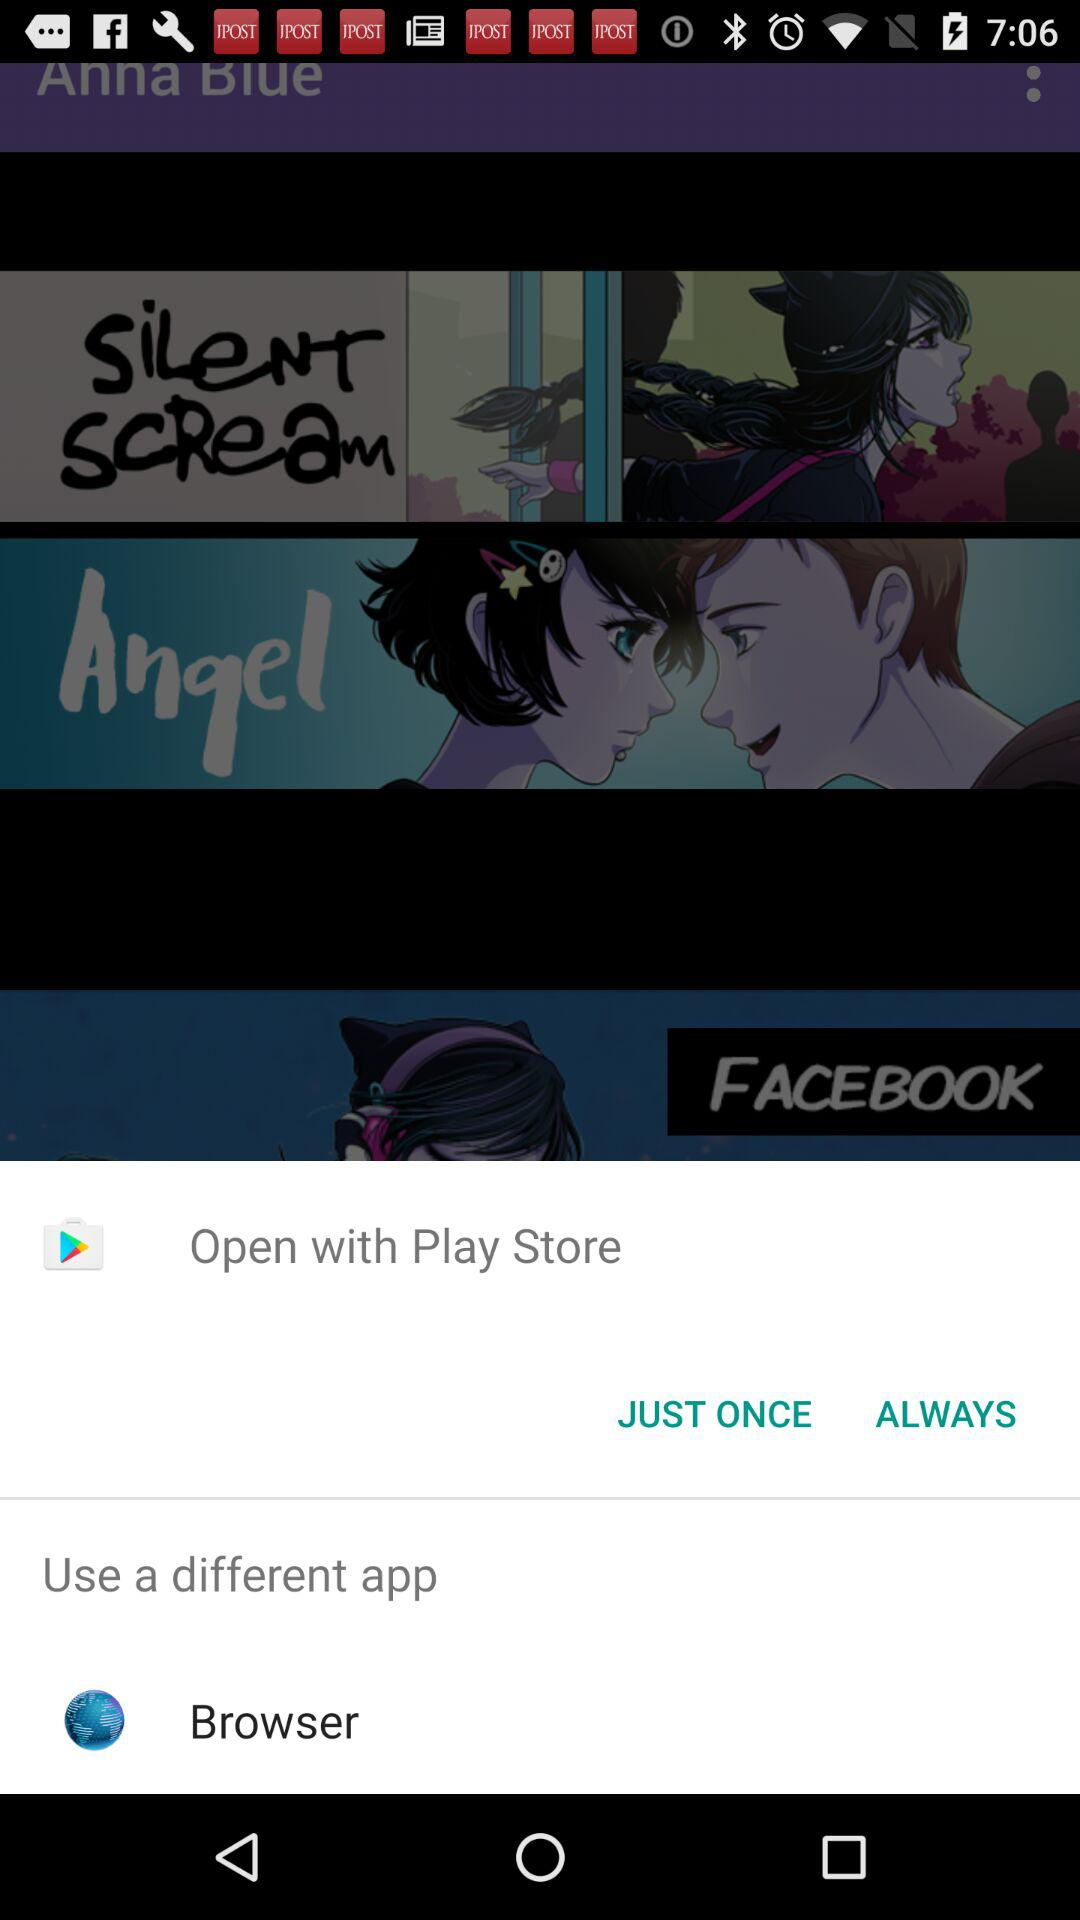Which applications can be used to open? The application that can be used is "Play Store". 